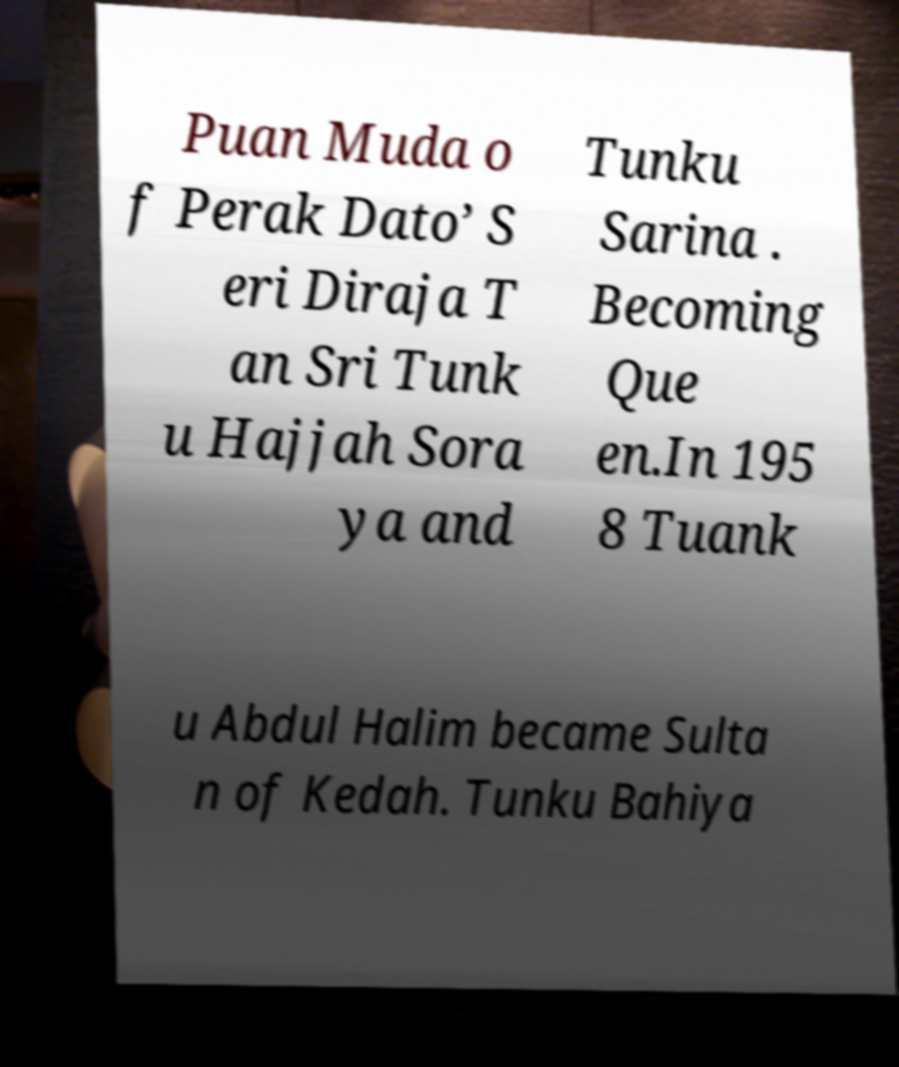Can you read and provide the text displayed in the image?This photo seems to have some interesting text. Can you extract and type it out for me? Puan Muda o f Perak Dato’ S eri Diraja T an Sri Tunk u Hajjah Sora ya and Tunku Sarina . Becoming Que en.In 195 8 Tuank u Abdul Halim became Sulta n of Kedah. Tunku Bahiya 